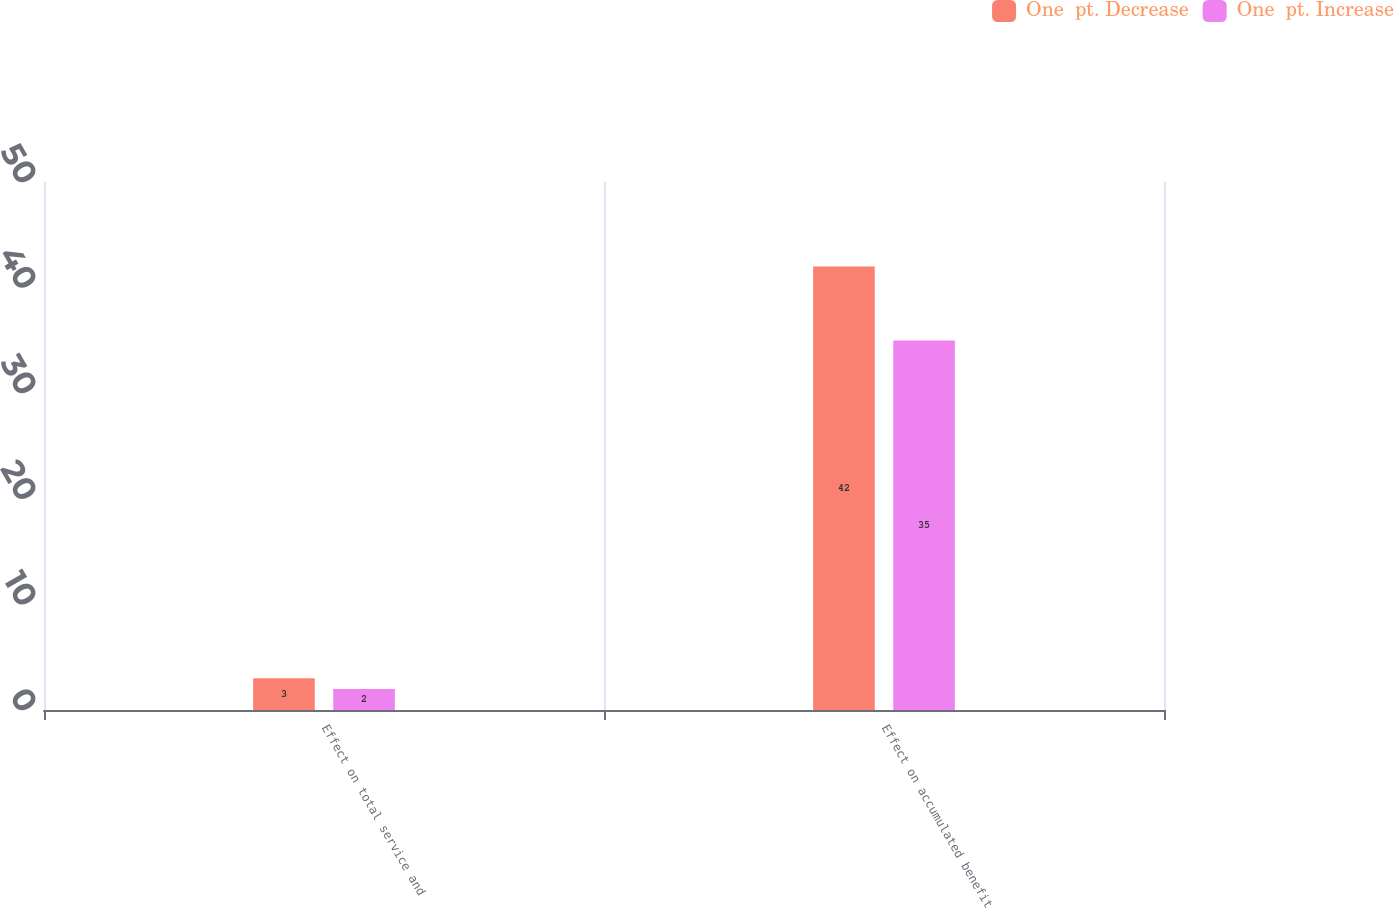Convert chart to OTSL. <chart><loc_0><loc_0><loc_500><loc_500><stacked_bar_chart><ecel><fcel>Effect on total service and<fcel>Effect on accumulated benefit<nl><fcel>One  pt. Decrease<fcel>3<fcel>42<nl><fcel>One  pt. Increase<fcel>2<fcel>35<nl></chart> 